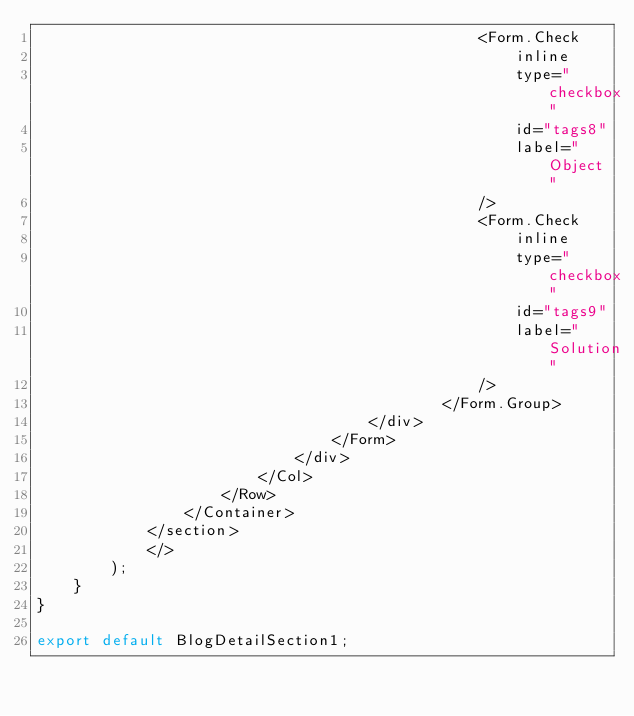Convert code to text. <code><loc_0><loc_0><loc_500><loc_500><_JavaScript_>                                                <Form.Check
                                                    inline
                                                    type="checkbox"
                                                    id="tags8"
                                                    label="Object"
                                                />
                                                <Form.Check
                                                    inline
                                                    type="checkbox"
                                                    id="tags9"
                                                    label="Solution"
                                                />
                                            </Form.Group>
                                    </div>
                                </Form>
                            </div>
                        </Col>
                    </Row>
                </Container>
            </section>
            </>
        );
    }
}

export default BlogDetailSection1;
</code> 